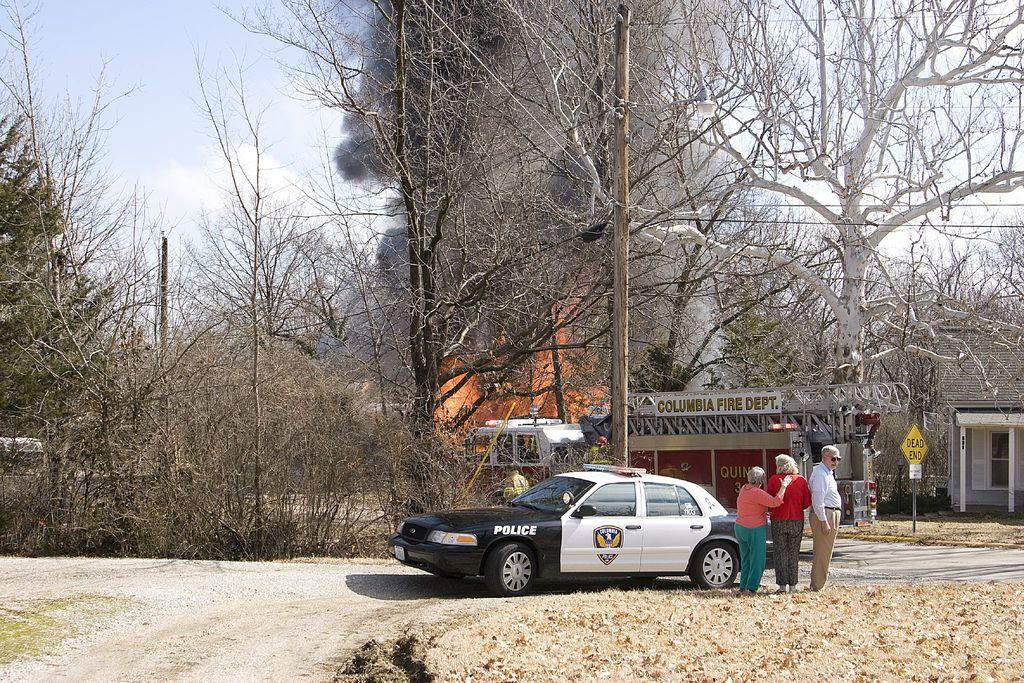What type of trees can be seen in the image? There are dry trees in the image. What type of establishments are present in the image? There are stores in the image. What type of transportation can be seen in the image? Vehicles are visible in the image. What type of structures are present in the image? There are buildings in the image. What type of openings are present in the buildings? Windows are present in the image. What type of signage is visible in the image? Signboards are visible in the image. What type of vertical structure is present in the image? There is a pole in the image. What type of atmospheric phenomenon is present in the image? Smoke is present in the image. What is the color of the sky in the image? The sky is white and blue in color. Can you tell me how many bags of popcorn are being sold in the image? There is no information about popcorn or any food items being sold in the image. What is the mother doing in the image? There is no mention of a mother or any person in the image. 